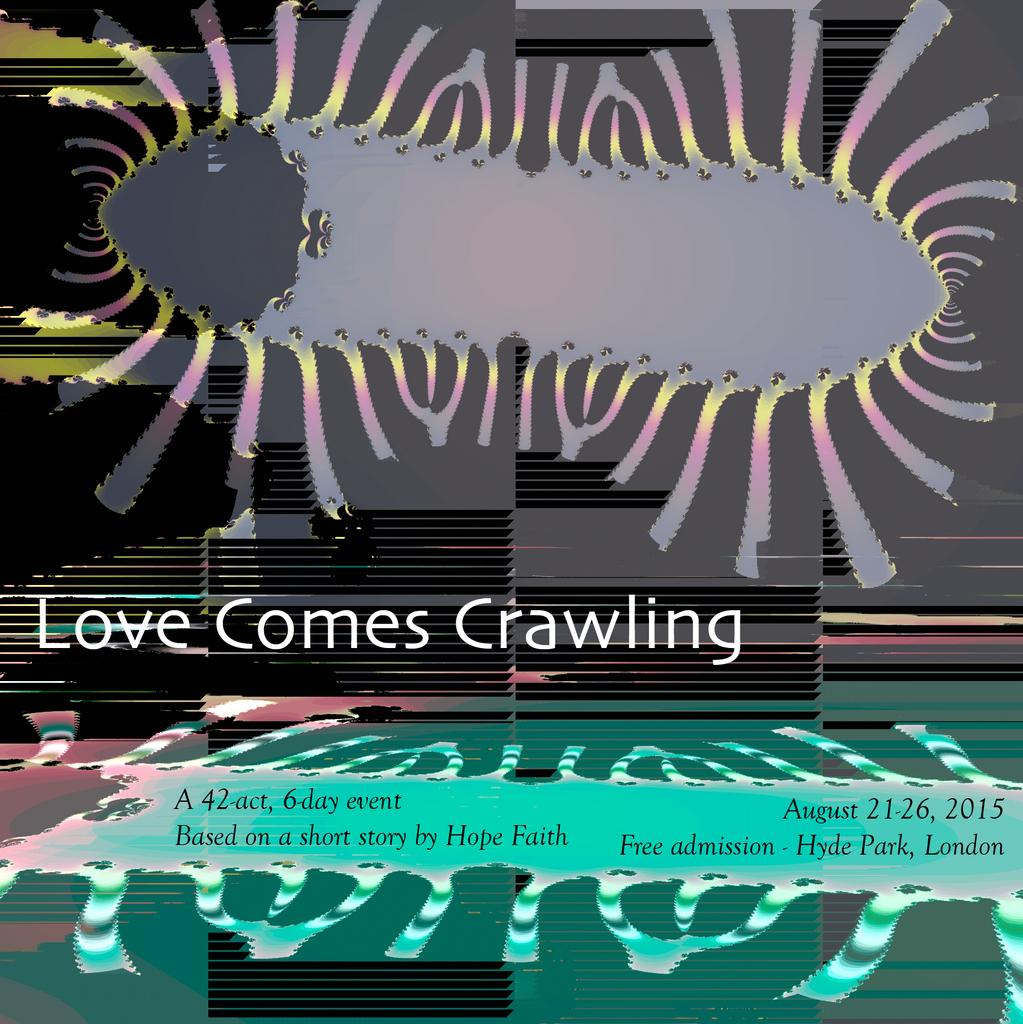<image>
Write a terse but informative summary of the picture. A poster advertising an event called Love Comes Crawling. 